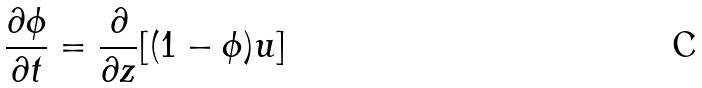<formula> <loc_0><loc_0><loc_500><loc_500>\frac { \partial \phi } { \partial t } = \frac { \partial } { \partial z } [ ( 1 - \phi ) u ]</formula> 